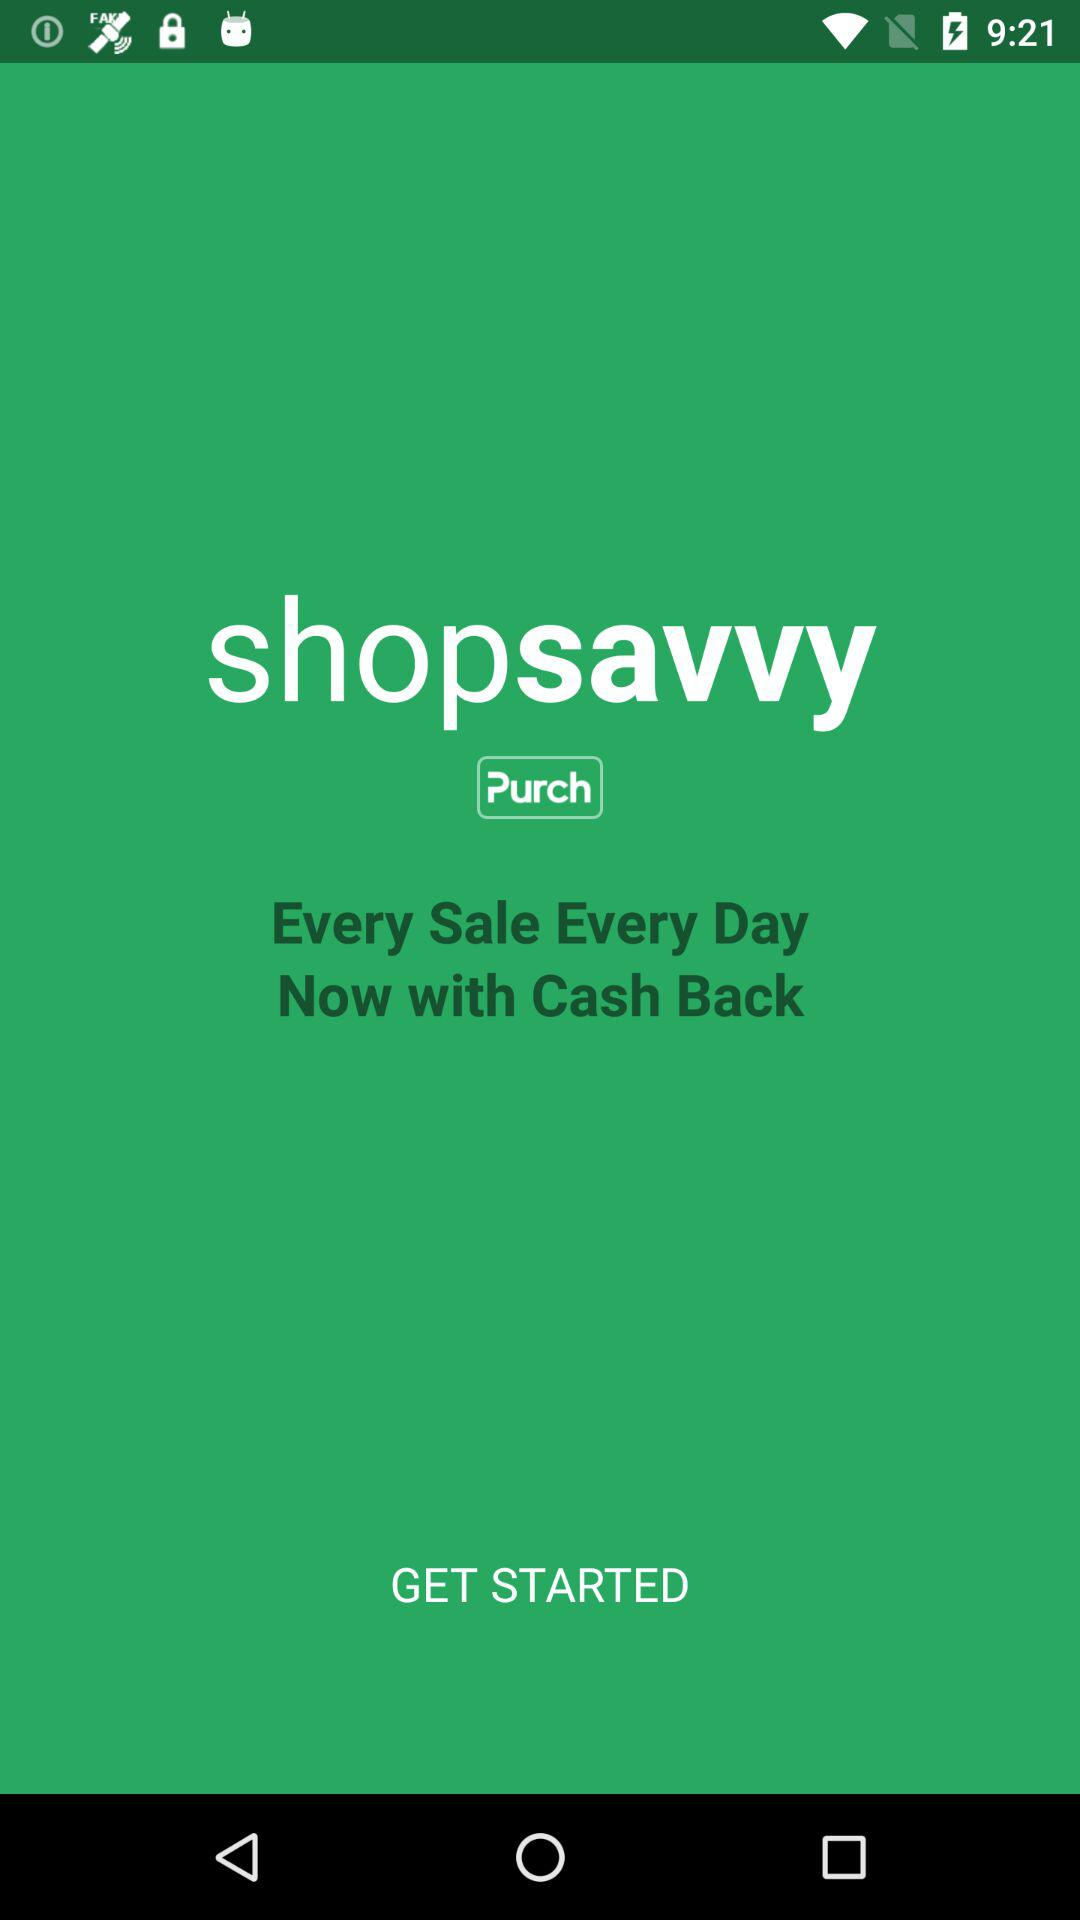What is the application name? The application name is "shopsavvy". 